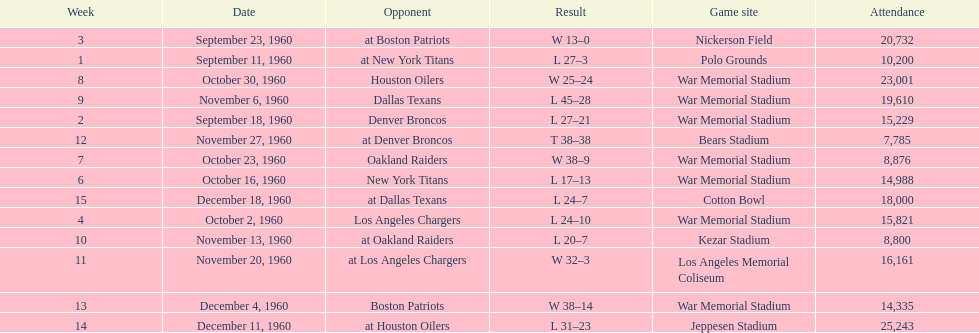What were the total number of games played in november? 4. 